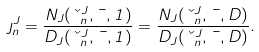<formula> <loc_0><loc_0><loc_500><loc_500>\eta ^ { J } _ { n } = \frac { N _ { J } ( \kappa ^ { J } _ { n } , \mu , 1 ) } { D _ { J } ( \kappa ^ { J } _ { n } , \mu , 1 ) } = \frac { N _ { J } ( \kappa ^ { J } _ { n } , \mu , D ) } { D _ { J } ( \kappa ^ { J } _ { n } , \mu , D ) } .</formula> 